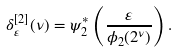<formula> <loc_0><loc_0><loc_500><loc_500>\delta ^ { [ 2 ] } _ { \varepsilon } ( \nu ) = \psi _ { 2 } ^ { * } \left ( \frac { \varepsilon } { \phi _ { 2 } ( 2 ^ { \nu } ) } \right ) .</formula> 